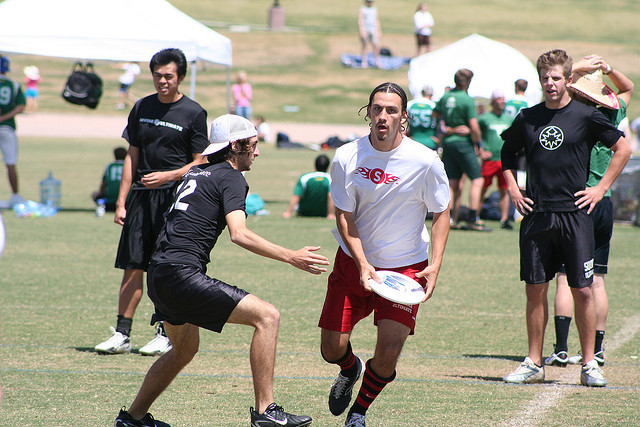Please transcribe the text information in this image. 12 S 